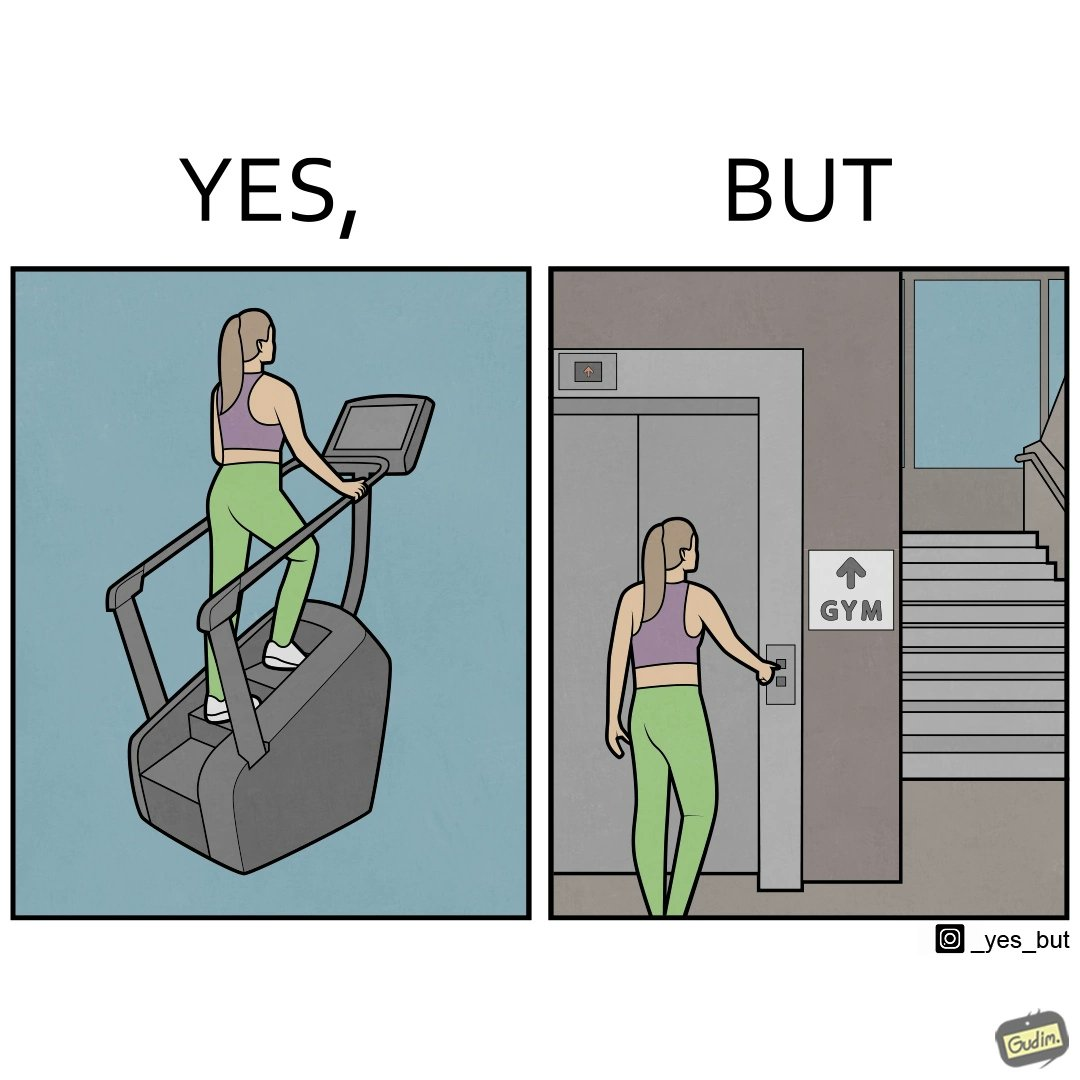Describe what you see in this image. The image is ironic, because in the left image a woman is seen using the stair climber machine at the gym but the same woman is not ready to climb up some stairs for going to the gym and is calling for the lift 